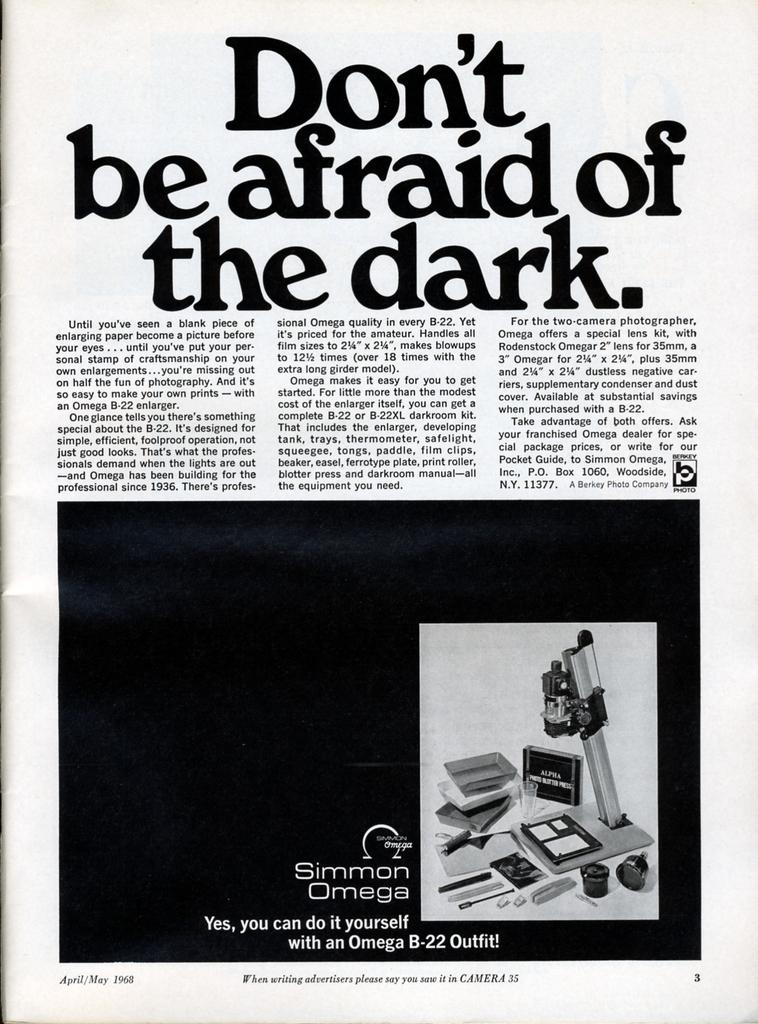<image>
Share a concise interpretation of the image provided. A magazine advertisement for the Simmon Omega photography equipment. 